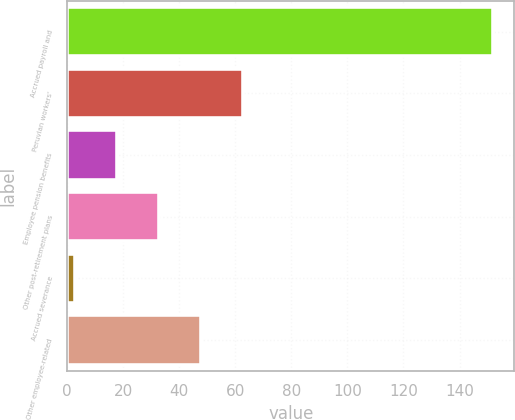Convert chart. <chart><loc_0><loc_0><loc_500><loc_500><bar_chart><fcel>Accrued payroll and<fcel>Peruvian workers'<fcel>Employee pension benefits<fcel>Other post-retirement plans<fcel>Accrued severance<fcel>Other employee-related<nl><fcel>152<fcel>62.6<fcel>17.9<fcel>32.8<fcel>3<fcel>47.7<nl></chart> 